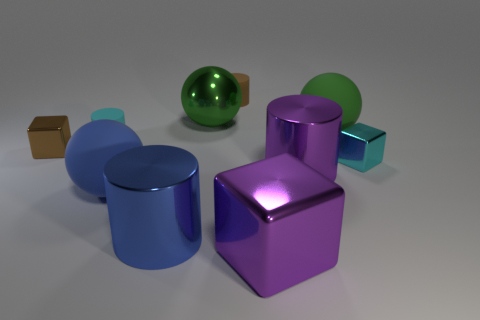Subtract all large green balls. How many balls are left? 1 Subtract 1 cylinders. How many cylinders are left? 3 Subtract all cyan cylinders. How many green balls are left? 2 Subtract all purple blocks. How many blocks are left? 2 Subtract all cylinders. How many objects are left? 6 Add 3 blue objects. How many blue objects are left? 5 Add 3 big yellow cylinders. How many big yellow cylinders exist? 3 Subtract 1 blue balls. How many objects are left? 9 Subtract all red cylinders. Subtract all red cubes. How many cylinders are left? 4 Subtract all cyan metallic spheres. Subtract all blue things. How many objects are left? 8 